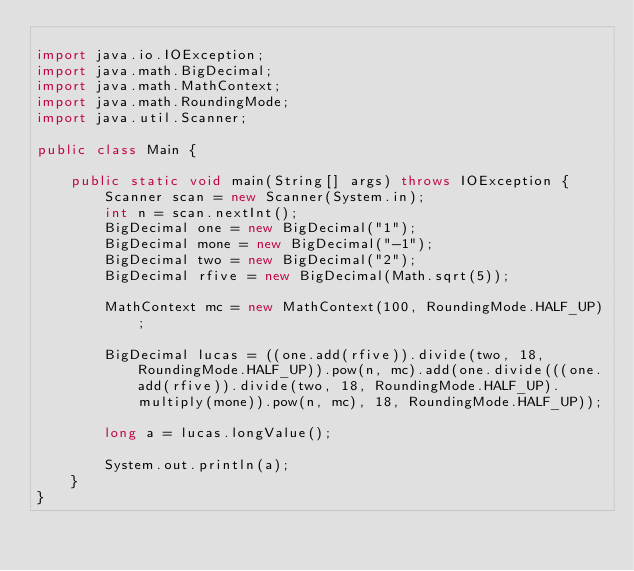<code> <loc_0><loc_0><loc_500><loc_500><_Java_>
import java.io.IOException;
import java.math.BigDecimal;
import java.math.MathContext;
import java.math.RoundingMode;
import java.util.Scanner;

public class Main {

	public static void main(String[] args) throws IOException {
		Scanner scan = new Scanner(System.in);
		int n = scan.nextInt();
		BigDecimal one = new BigDecimal("1");
		BigDecimal mone = new BigDecimal("-1");
		BigDecimal two = new BigDecimal("2");
		BigDecimal rfive = new BigDecimal(Math.sqrt(5));

		MathContext mc = new MathContext(100, RoundingMode.HALF_UP);

		BigDecimal lucas = ((one.add(rfive)).divide(two, 18, RoundingMode.HALF_UP)).pow(n, mc).add(one.divide(((one.add(rfive)).divide(two, 18, RoundingMode.HALF_UP).multiply(mone)).pow(n, mc), 18, RoundingMode.HALF_UP));

		long a = lucas.longValue();

		System.out.println(a);
	}
}
</code> 